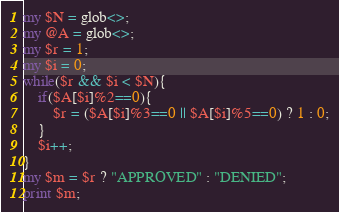<code> <loc_0><loc_0><loc_500><loc_500><_Perl_>my $N = glob<>;
my @A = glob<>;
my $r = 1;
my $i = 0;
while($r && $i < $N){
    if($A[$i]%2==0){
        $r = ($A[$i]%3==0 || $A[$i]%5==0) ? 1 : 0;
    }
    $i++;
}
my $m = $r ? "APPROVED" : "DENIED";
print $m;</code> 